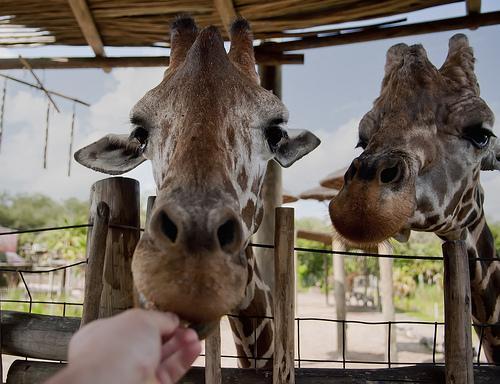How many giraffes are in the photo?
Give a very brief answer. 2. 